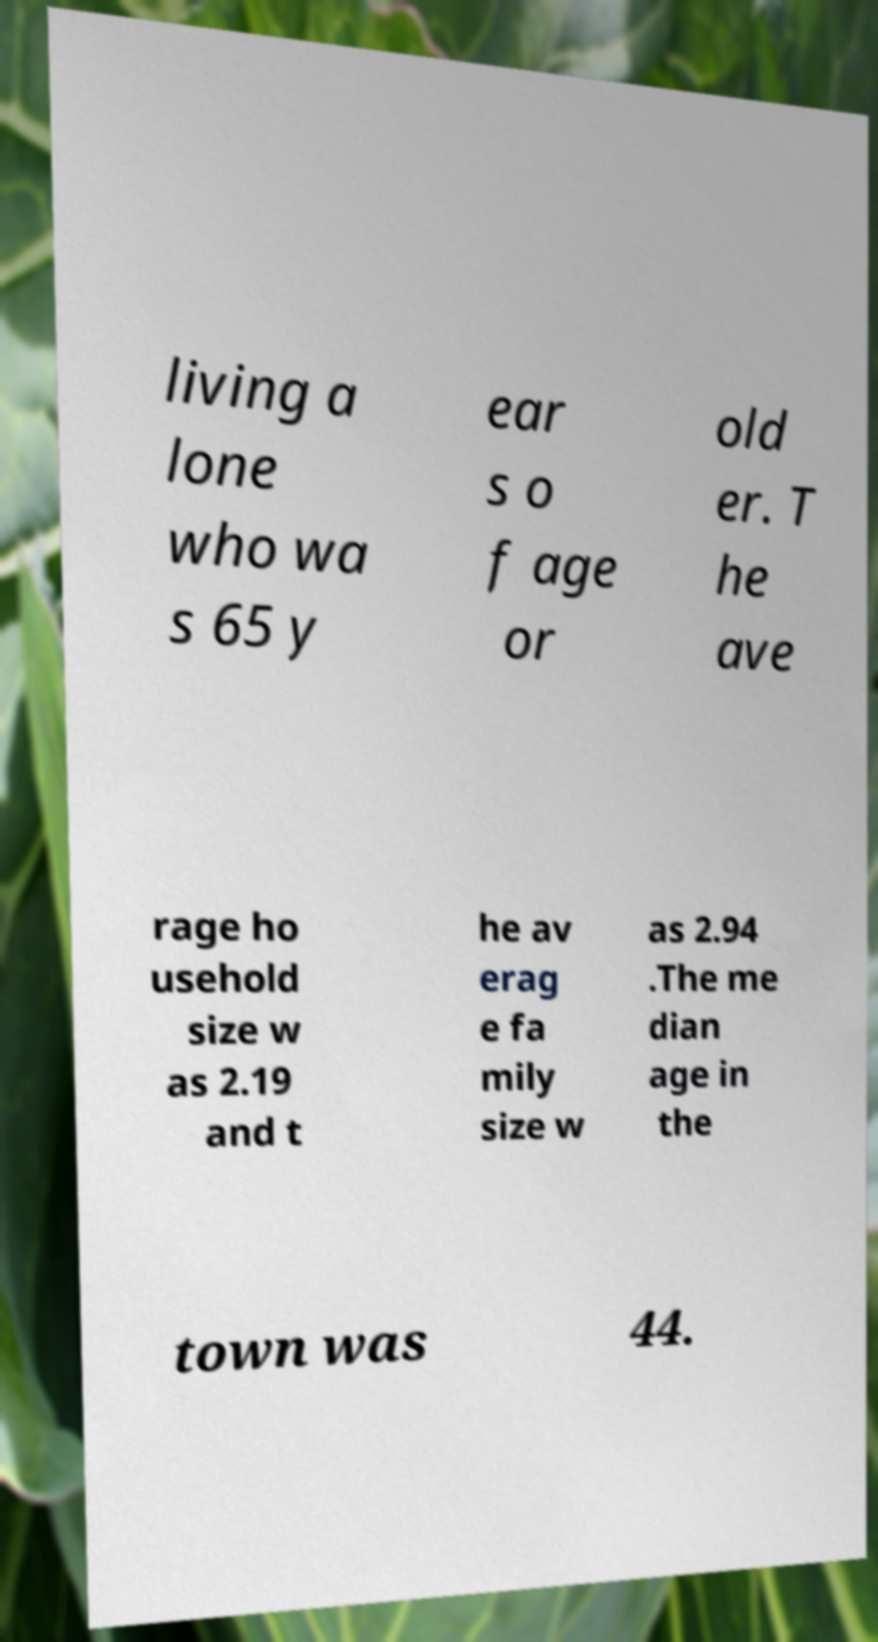What messages or text are displayed in this image? I need them in a readable, typed format. living a lone who wa s 65 y ear s o f age or old er. T he ave rage ho usehold size w as 2.19 and t he av erag e fa mily size w as 2.94 .The me dian age in the town was 44. 